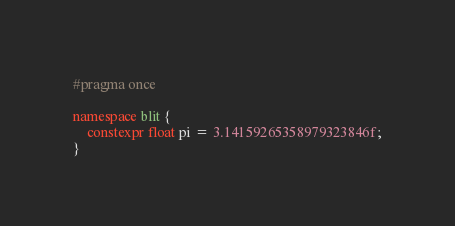Convert code to text. <code><loc_0><loc_0><loc_500><loc_500><_C++_>#pragma once

namespace blit {
    constexpr float pi = 3.14159265358979323846f;
}</code> 